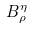<formula> <loc_0><loc_0><loc_500><loc_500>B _ { \rho } ^ { \eta }</formula> 